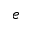Convert formula to latex. <formula><loc_0><loc_0><loc_500><loc_500>e</formula> 